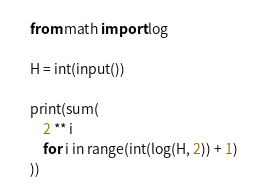Convert code to text. <code><loc_0><loc_0><loc_500><loc_500><_Python_>from math import log

H = int(input())

print(sum(
    2 ** i
    for i in range(int(log(H, 2)) + 1)
))</code> 